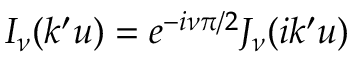<formula> <loc_0><loc_0><loc_500><loc_500>I _ { \nu } ( k ^ { \prime } u ) = e ^ { - i \nu \pi / 2 } J _ { \nu } ( i k ^ { \prime } u )</formula> 